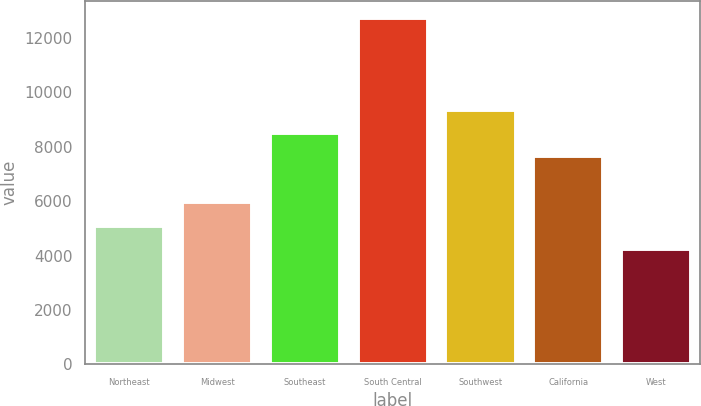Convert chart to OTSL. <chart><loc_0><loc_0><loc_500><loc_500><bar_chart><fcel>Northeast<fcel>Midwest<fcel>Southeast<fcel>South Central<fcel>Southwest<fcel>California<fcel>West<nl><fcel>5090.6<fcel>5977<fcel>8520.6<fcel>12737<fcel>9370.2<fcel>7671<fcel>4241<nl></chart> 